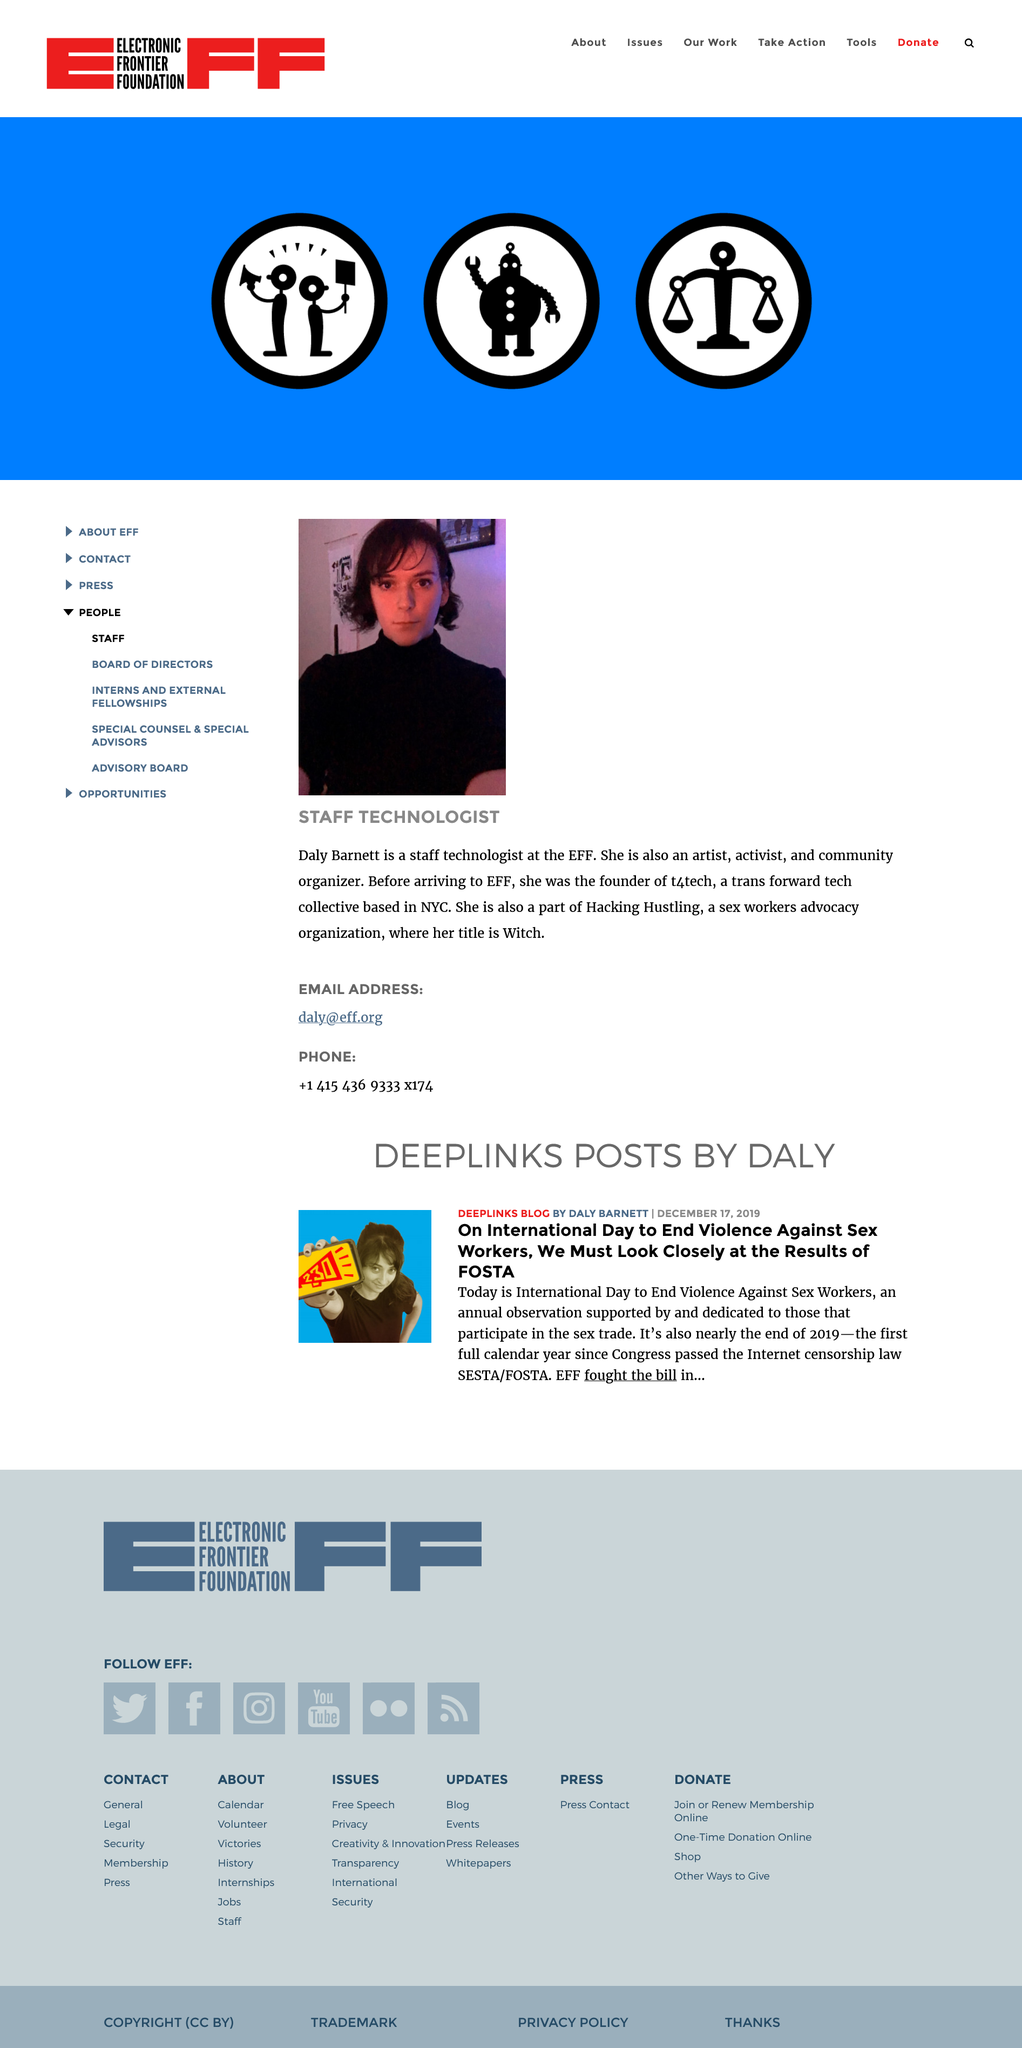Indicate a few pertinent items in this graphic. Hacking Hustling is a sex workers advocacy organization dedicated to promoting the rights and interests of sex workers and ending the stigma surrounding the profession. Daly's job title is Staff Technologist. This page is dedicated to Daly Barnett. 